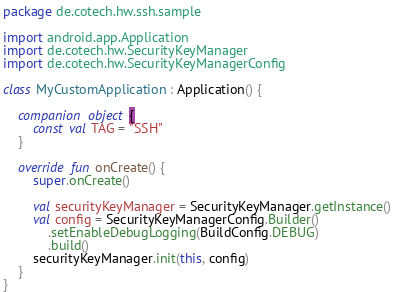<code> <loc_0><loc_0><loc_500><loc_500><_Kotlin_>package de.cotech.hw.ssh.sample

import android.app.Application
import de.cotech.hw.SecurityKeyManager
import de.cotech.hw.SecurityKeyManagerConfig

class MyCustomApplication : Application() {

    companion object {
        const val TAG = "SSH"
    }

    override fun onCreate() {
        super.onCreate()

        val securityKeyManager = SecurityKeyManager.getInstance()
        val config = SecurityKeyManagerConfig.Builder()
            .setEnableDebugLogging(BuildConfig.DEBUG)
            .build()
        securityKeyManager.init(this, config)
    }
}
</code> 